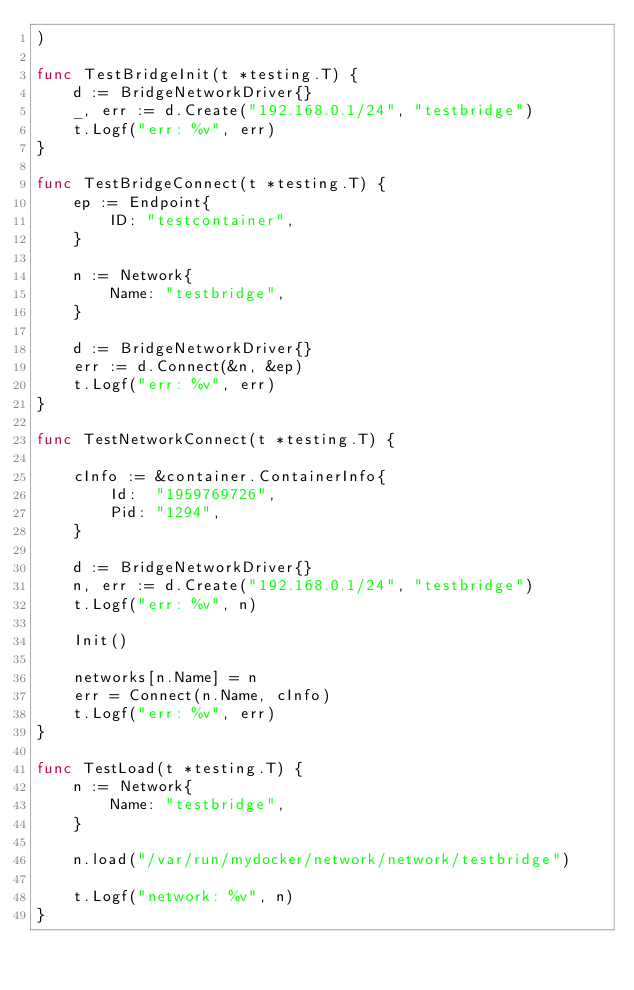<code> <loc_0><loc_0><loc_500><loc_500><_Go_>)

func TestBridgeInit(t *testing.T) {
	d := BridgeNetworkDriver{}
	_, err := d.Create("192.168.0.1/24", "testbridge")
	t.Logf("err: %v", err)
}

func TestBridgeConnect(t *testing.T) {
	ep := Endpoint{
		ID: "testcontainer",
	}

	n := Network{
		Name: "testbridge",
	}

	d := BridgeNetworkDriver{}
	err := d.Connect(&n, &ep)
	t.Logf("err: %v", err)
}

func TestNetworkConnect(t *testing.T) {

	cInfo := &container.ContainerInfo{
		Id:  "1959769726",
		Pid: "1294",
	}

	d := BridgeNetworkDriver{}
	n, err := d.Create("192.168.0.1/24", "testbridge")
	t.Logf("err: %v", n)

	Init()

	networks[n.Name] = n
	err = Connect(n.Name, cInfo)
	t.Logf("err: %v", err)
}

func TestLoad(t *testing.T) {
	n := Network{
		Name: "testbridge",
	}

	n.load("/var/run/mydocker/network/network/testbridge")

	t.Logf("network: %v", n)
}
</code> 